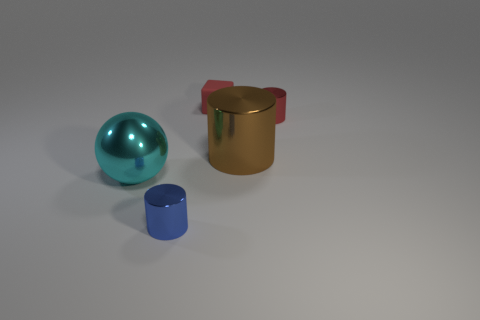Subtract all blue cylinders. Subtract all cyan blocks. How many cylinders are left? 2 Add 1 cylinders. How many objects exist? 6 Subtract all spheres. How many objects are left? 4 Subtract all matte things. Subtract all big shiny cylinders. How many objects are left? 3 Add 1 big cyan objects. How many big cyan objects are left? 2 Add 3 blue things. How many blue things exist? 4 Subtract 0 cyan blocks. How many objects are left? 5 